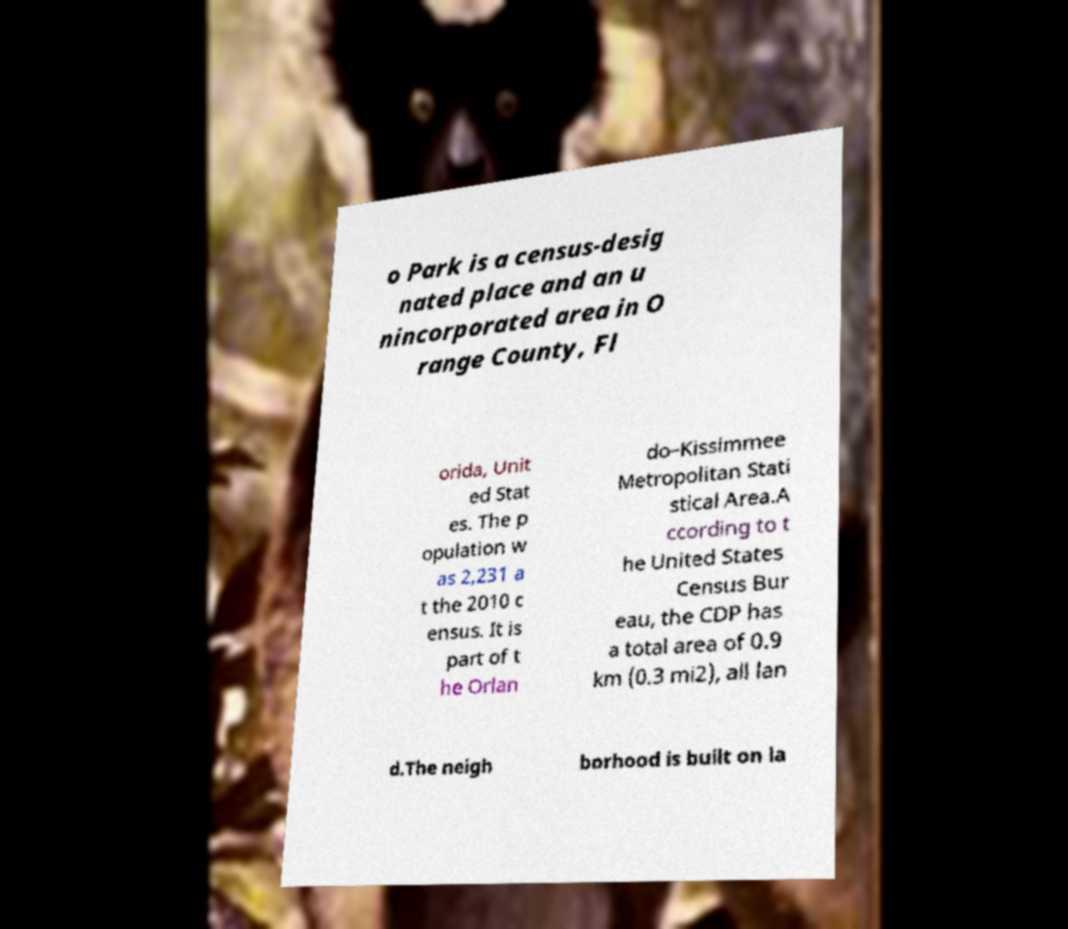Please read and relay the text visible in this image. What does it say? o Park is a census-desig nated place and an u nincorporated area in O range County, Fl orida, Unit ed Stat es. The p opulation w as 2,231 a t the 2010 c ensus. It is part of t he Orlan do–Kissimmee Metropolitan Stati stical Area.A ccording to t he United States Census Bur eau, the CDP has a total area of 0.9 km (0.3 mi2), all lan d.The neigh borhood is built on la 